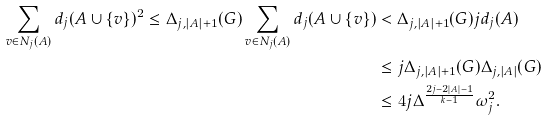Convert formula to latex. <formula><loc_0><loc_0><loc_500><loc_500>\sum _ { v \in N _ { j } ( A ) } d _ { j } ( A \cup \{ v \} ) ^ { 2 } \leq \Delta _ { j , | A | + 1 } ( G ) \sum _ { v \in N _ { j } ( A ) } d _ { j } ( A \cup \{ v \} ) & < \Delta _ { j , | A | + 1 } ( G ) j d _ { j } ( A ) \\ & \leq j \Delta _ { j , | A | + 1 } ( G ) \Delta _ { j , | A | } ( G ) \\ & \leq 4 j \Delta ^ { \frac { 2 j - 2 | A | - 1 } { k - 1 } } \omega _ { j } ^ { 2 } .</formula> 